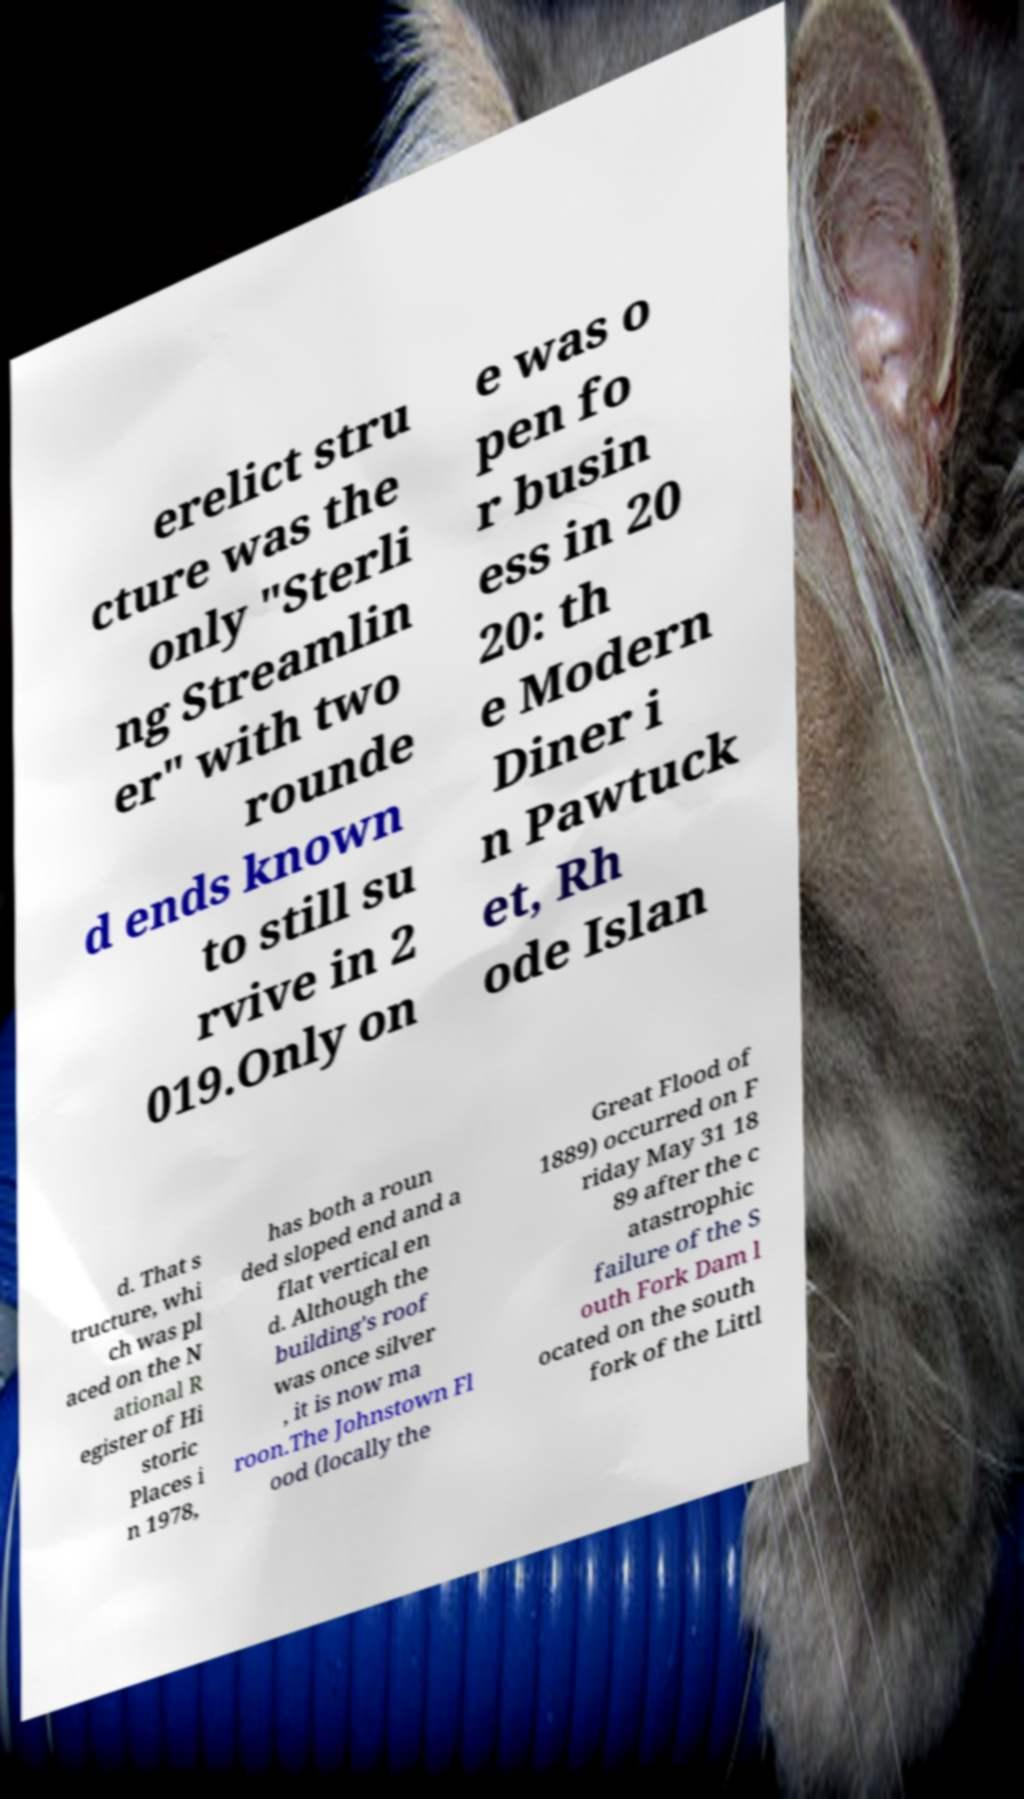There's text embedded in this image that I need extracted. Can you transcribe it verbatim? erelict stru cture was the only "Sterli ng Streamlin er" with two rounde d ends known to still su rvive in 2 019.Only on e was o pen fo r busin ess in 20 20: th e Modern Diner i n Pawtuck et, Rh ode Islan d. That s tructure, whi ch was pl aced on the N ational R egister of Hi storic Places i n 1978, has both a roun ded sloped end and a flat vertical en d. Although the building's roof was once silver , it is now ma roon.The Johnstown Fl ood (locally the Great Flood of 1889) occurred on F riday May 31 18 89 after the c atastrophic failure of the S outh Fork Dam l ocated on the south fork of the Littl 